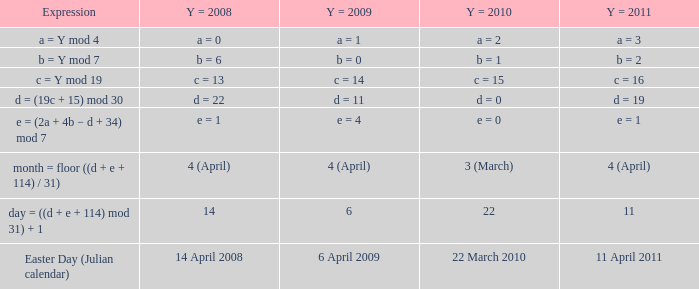What is the y = 2011 when the y = 2010  is 22 march 2010? 11 April 2011. 